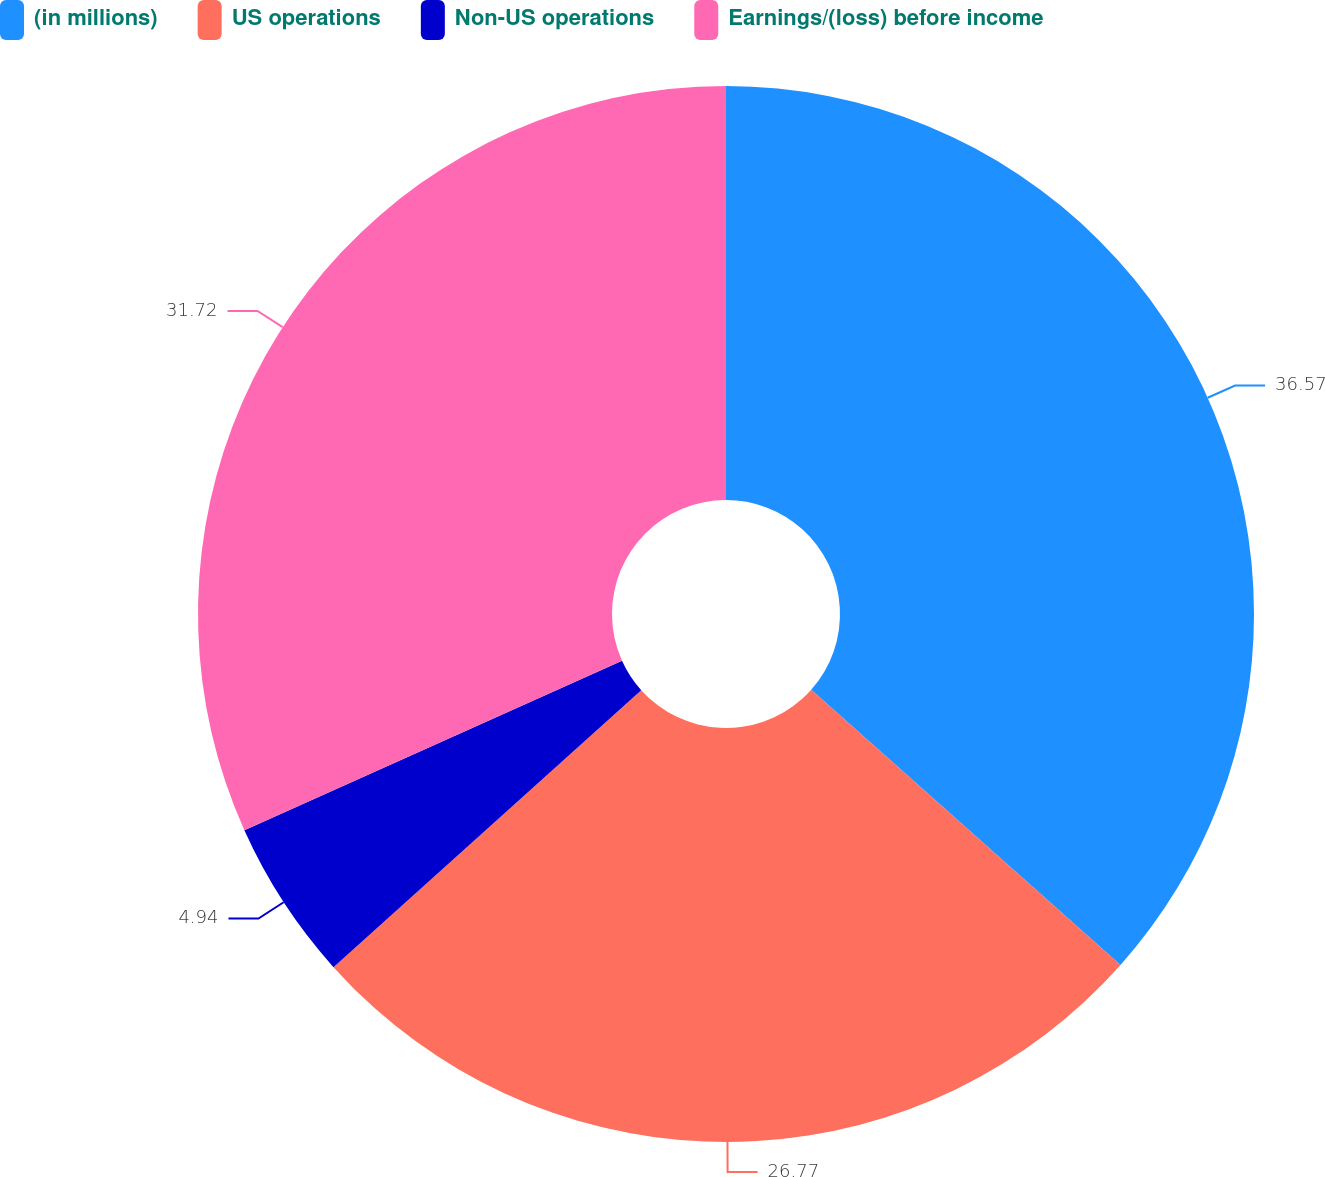Convert chart to OTSL. <chart><loc_0><loc_0><loc_500><loc_500><pie_chart><fcel>(in millions)<fcel>US operations<fcel>Non-US operations<fcel>Earnings/(loss) before income<nl><fcel>36.57%<fcel>26.77%<fcel>4.94%<fcel>31.72%<nl></chart> 